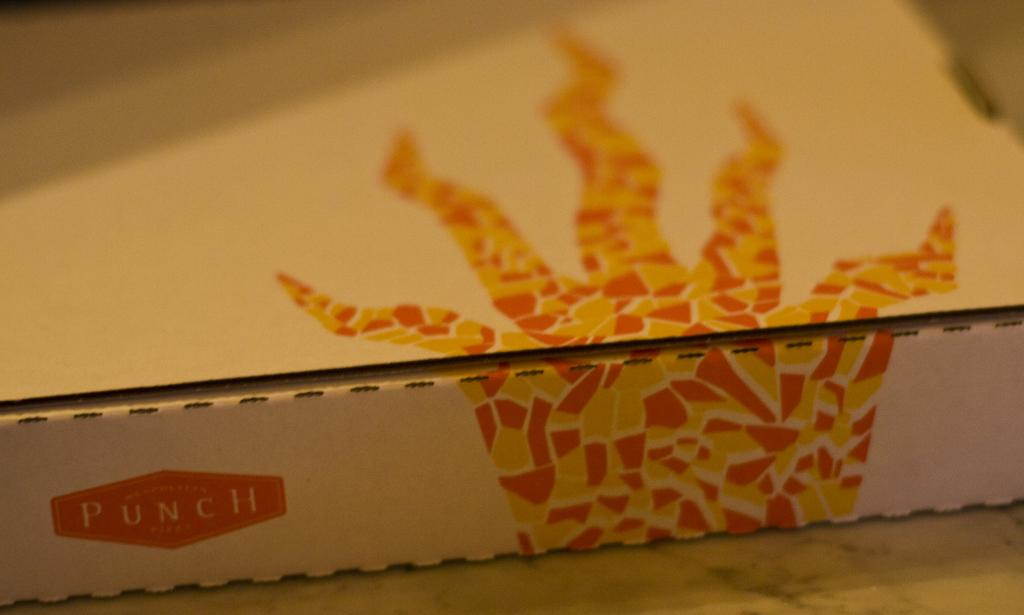<image>
Provide a brief description of the given image. Punch is the name on the pizza box 